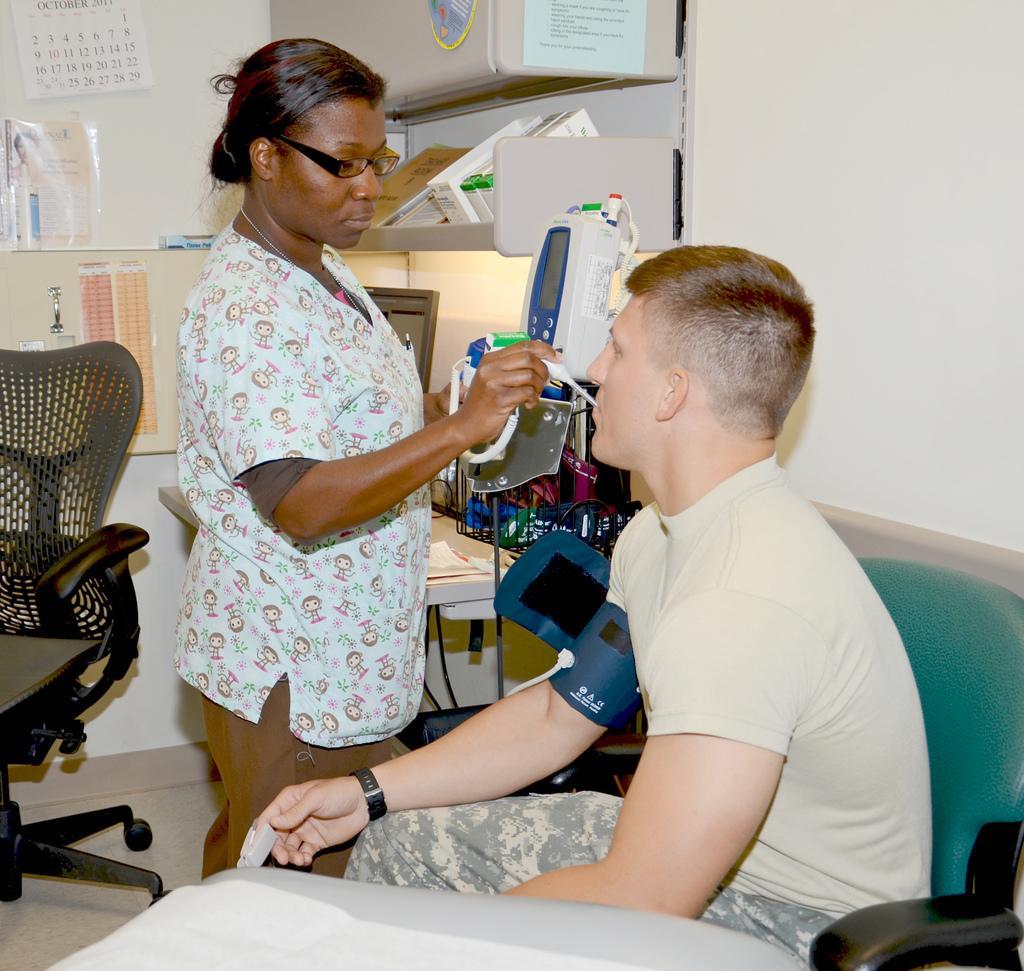Please provide a concise description of this image. On the left side of the image we can see a chair, calendar and a poster. In the middle of the image we can see a lady is standing and keeping a machine in a person's mouth. On the right side of the image we can see a person is sitting on the chair and kept a blood pressure machine to his hand. 